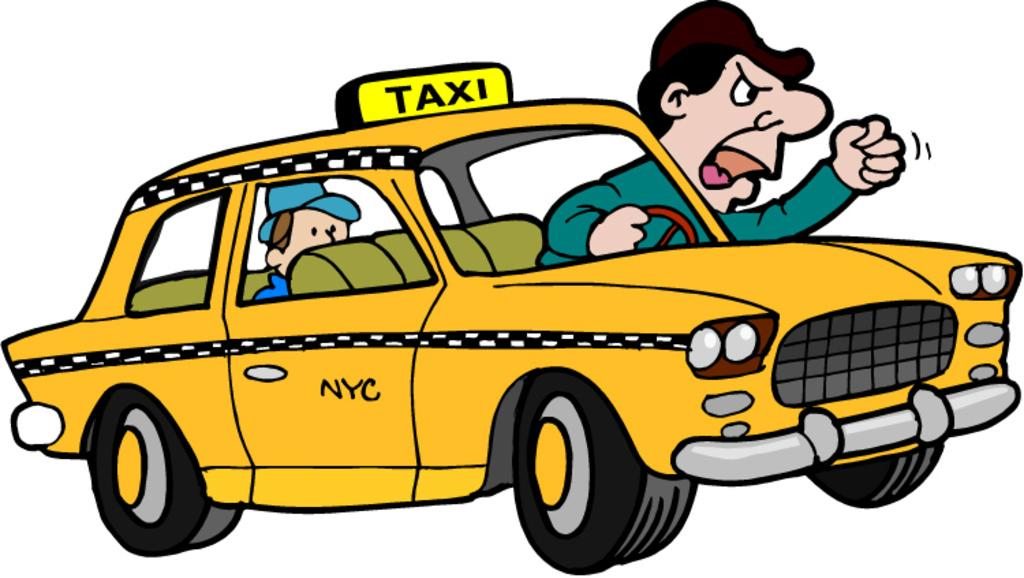<image>
Provide a brief description of the given image. The driver of a taxi that says NYC is leaning out of the window and yelling. 